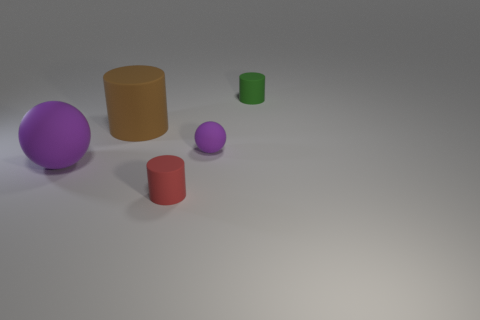How many other things are there of the same size as the brown object?
Provide a short and direct response. 1. How big is the rubber object that is both on the left side of the small red object and in front of the brown cylinder?
Your answer should be compact. Large. There is a big matte sphere; is it the same color as the small ball that is to the right of the big matte sphere?
Make the answer very short. Yes. Are there any other big things of the same shape as the large purple object?
Offer a very short reply. No. What number of things are either large brown rubber objects or purple balls that are on the left side of the small purple matte sphere?
Provide a short and direct response. 2. How many other objects are the same material as the big purple ball?
Give a very brief answer. 4. How many things are either small purple rubber spheres or gray rubber blocks?
Ensure brevity in your answer.  1. Is the number of tiny purple rubber spheres to the left of the tiny matte ball greater than the number of big purple matte things that are behind the small green object?
Ensure brevity in your answer.  No. Does the rubber ball on the left side of the small red object have the same color as the rubber ball that is behind the large matte sphere?
Offer a terse response. Yes. There is a matte object in front of the purple thing that is on the left side of the tiny rubber cylinder that is in front of the small green thing; what is its size?
Offer a terse response. Small. 